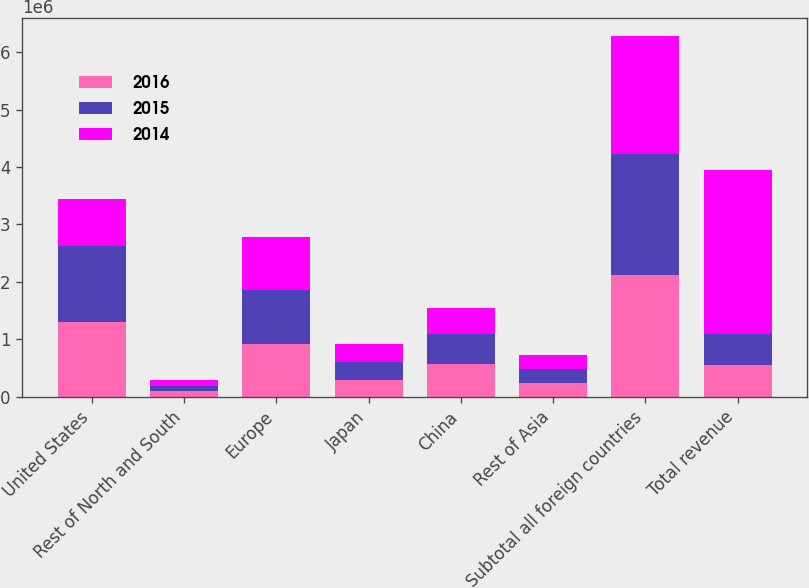Convert chart. <chart><loc_0><loc_0><loc_500><loc_500><stacked_bar_chart><ecel><fcel>United States<fcel>Rest of North and South<fcel>Europe<fcel>Japan<fcel>China<fcel>Rest of Asia<fcel>Subtotal all foreign countries<fcel>Total revenue<nl><fcel>2016<fcel>1.29963e+06<fcel>95957<fcel>924849<fcel>291649<fcel>575690<fcel>233635<fcel>2.12178e+06<fcel>543528<nl><fcel>2015<fcel>1.32528e+06<fcel>97189<fcel>939230<fcel>319569<fcel>511365<fcel>242460<fcel>2.10981e+06<fcel>543528<nl><fcel>2014<fcel>821554<fcel>96957<fcel>924477<fcel>308054<fcel>459260<fcel>254471<fcel>2.04322e+06<fcel>2.86477e+06<nl></chart> 